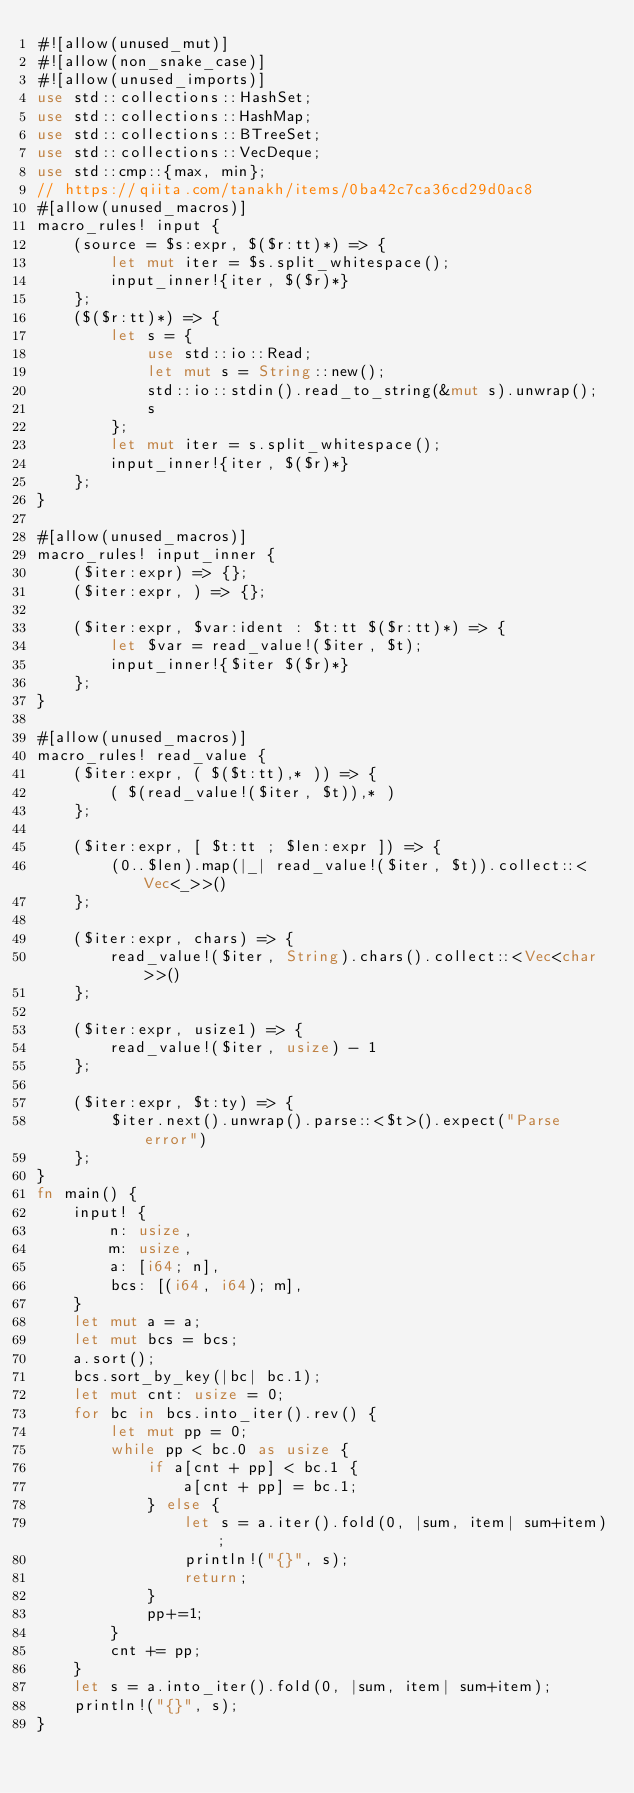Convert code to text. <code><loc_0><loc_0><loc_500><loc_500><_Rust_>#![allow(unused_mut)]
#![allow(non_snake_case)]
#![allow(unused_imports)]
use std::collections::HashSet;
use std::collections::HashMap;
use std::collections::BTreeSet;
use std::collections::VecDeque;
use std::cmp::{max, min};
// https://qiita.com/tanakh/items/0ba42c7ca36cd29d0ac8
#[allow(unused_macros)]
macro_rules! input {
    (source = $s:expr, $($r:tt)*) => {
        let mut iter = $s.split_whitespace();
        input_inner!{iter, $($r)*}
    };
    ($($r:tt)*) => {
        let s = {
            use std::io::Read;
            let mut s = String::new();
            std::io::stdin().read_to_string(&mut s).unwrap();
            s
        };
        let mut iter = s.split_whitespace();
        input_inner!{iter, $($r)*}
    };
}

#[allow(unused_macros)]
macro_rules! input_inner {
    ($iter:expr) => {};
    ($iter:expr, ) => {};

    ($iter:expr, $var:ident : $t:tt $($r:tt)*) => {
        let $var = read_value!($iter, $t);
        input_inner!{$iter $($r)*}
    };
}

#[allow(unused_macros)]
macro_rules! read_value {
    ($iter:expr, ( $($t:tt),* )) => {
        ( $(read_value!($iter, $t)),* )
    };

    ($iter:expr, [ $t:tt ; $len:expr ]) => {
        (0..$len).map(|_| read_value!($iter, $t)).collect::<Vec<_>>()
    };

    ($iter:expr, chars) => {
        read_value!($iter, String).chars().collect::<Vec<char>>()
    };

    ($iter:expr, usize1) => {
        read_value!($iter, usize) - 1
    };

    ($iter:expr, $t:ty) => {
        $iter.next().unwrap().parse::<$t>().expect("Parse error")
    };
}
fn main() {
    input! {
        n: usize,
        m: usize,
        a: [i64; n],
        bcs: [(i64, i64); m],
    }
    let mut a = a;
    let mut bcs = bcs;
    a.sort();
    bcs.sort_by_key(|bc| bc.1);
    let mut cnt: usize = 0;
    for bc in bcs.into_iter().rev() {
        let mut pp = 0;
        while pp < bc.0 as usize {
            if a[cnt + pp] < bc.1 {
                a[cnt + pp] = bc.1;
            } else {
                let s = a.iter().fold(0, |sum, item| sum+item);
                println!("{}", s);
                return;
            }
            pp+=1;
        }
        cnt += pp;
    }
    let s = a.into_iter().fold(0, |sum, item| sum+item);
    println!("{}", s);
}</code> 